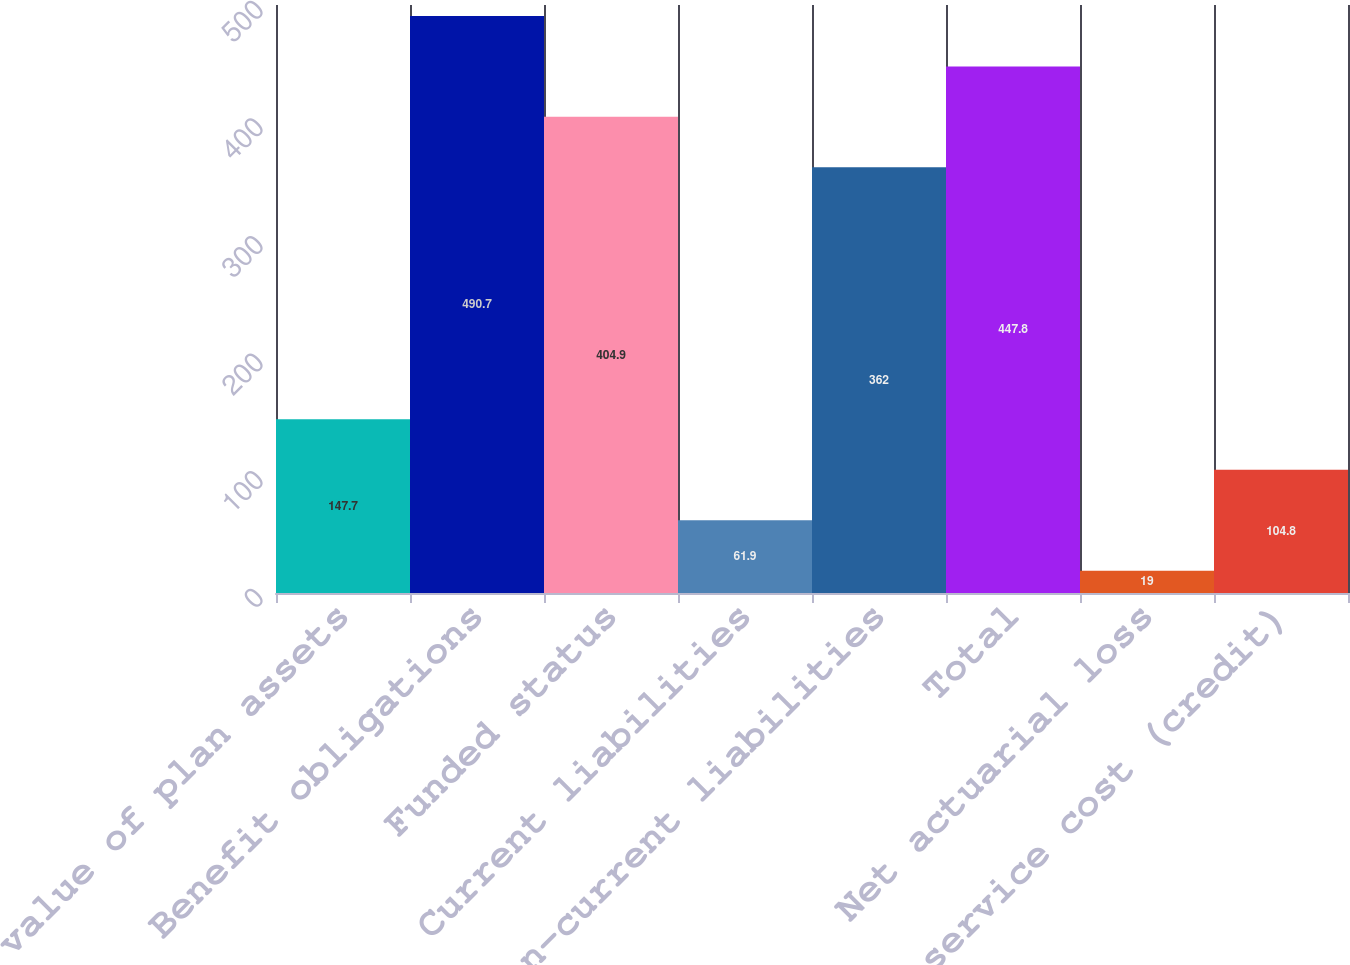Convert chart. <chart><loc_0><loc_0><loc_500><loc_500><bar_chart><fcel>Fair value of plan assets<fcel>Benefit obligations<fcel>Funded status<fcel>Current liabilities<fcel>Non-current liabilities<fcel>Total<fcel>Net actuarial loss<fcel>Prior service cost (credit)<nl><fcel>147.7<fcel>490.7<fcel>404.9<fcel>61.9<fcel>362<fcel>447.8<fcel>19<fcel>104.8<nl></chart> 